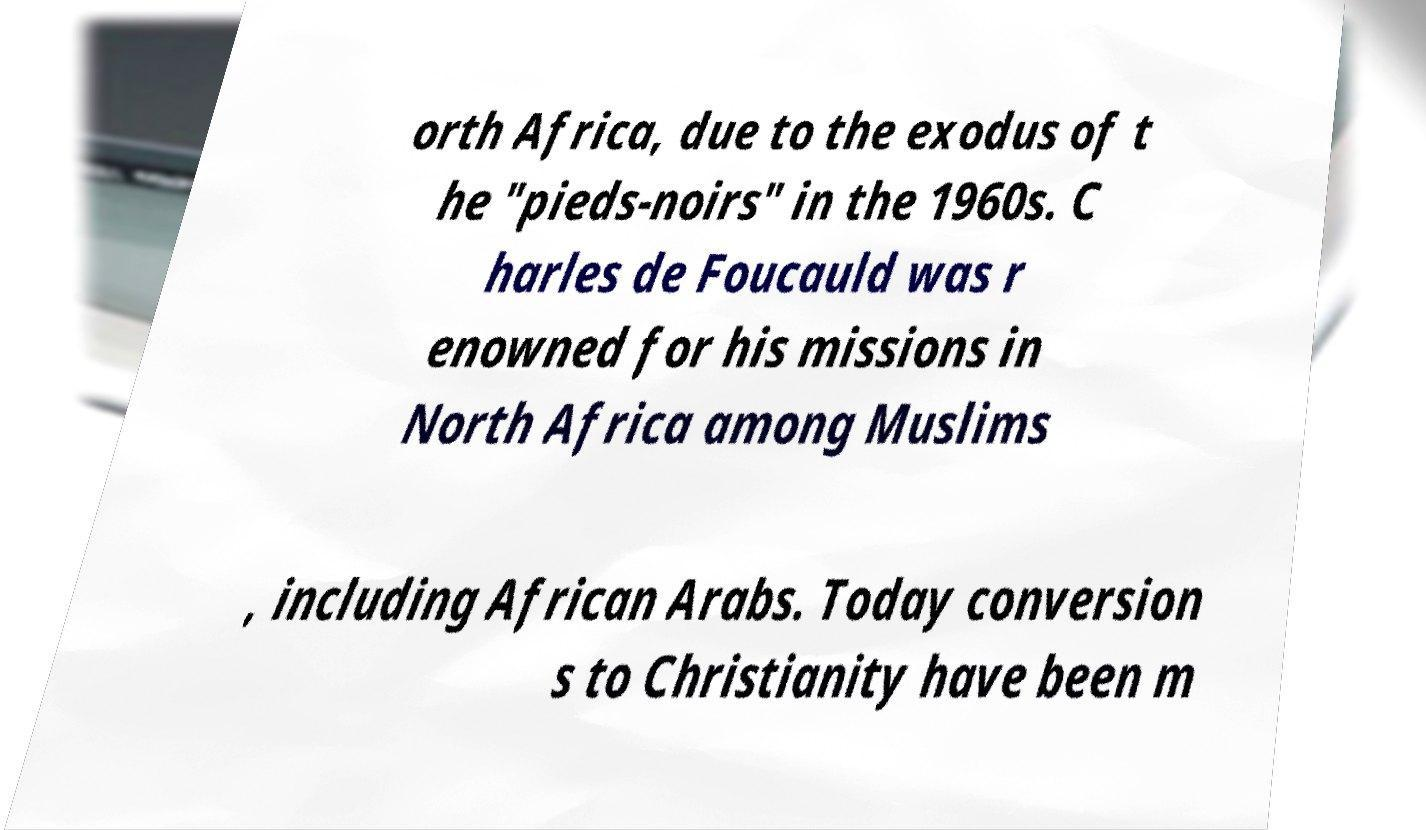Can you read and provide the text displayed in the image?This photo seems to have some interesting text. Can you extract and type it out for me? orth Africa, due to the exodus of t he "pieds-noirs" in the 1960s. C harles de Foucauld was r enowned for his missions in North Africa among Muslims , including African Arabs. Today conversion s to Christianity have been m 